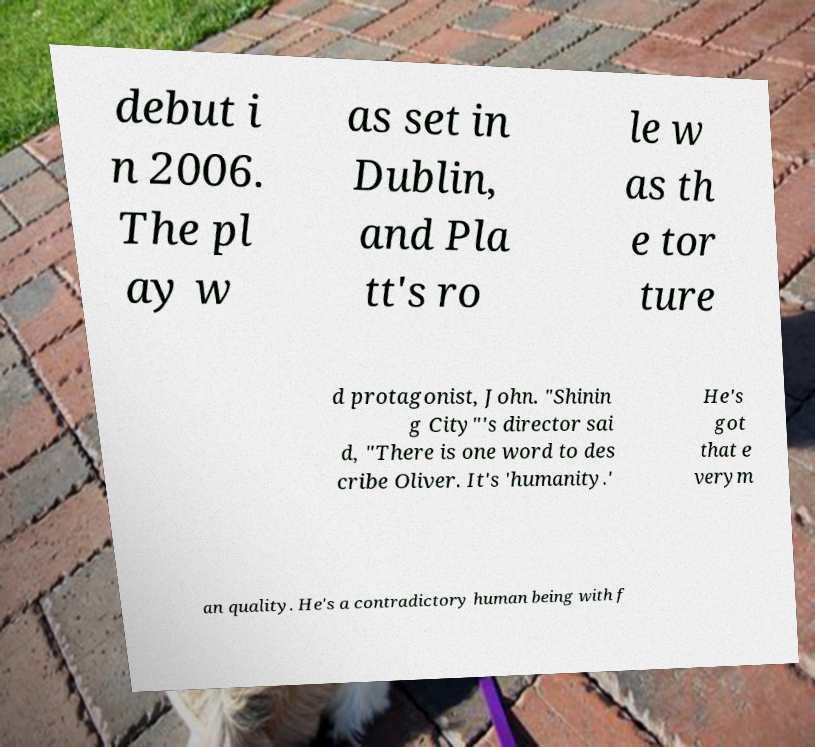Can you read and provide the text displayed in the image?This photo seems to have some interesting text. Can you extract and type it out for me? debut i n 2006. The pl ay w as set in Dublin, and Pla tt's ro le w as th e tor ture d protagonist, John. "Shinin g City"'s director sai d, "There is one word to des cribe Oliver. It's 'humanity.' He's got that e verym an quality. He's a contradictory human being with f 